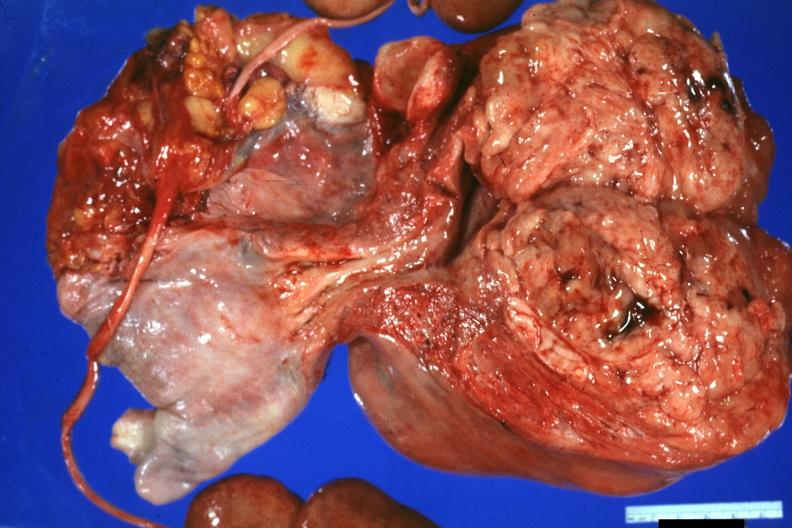s uterus present?
Answer the question using a single word or phrase. Yes 